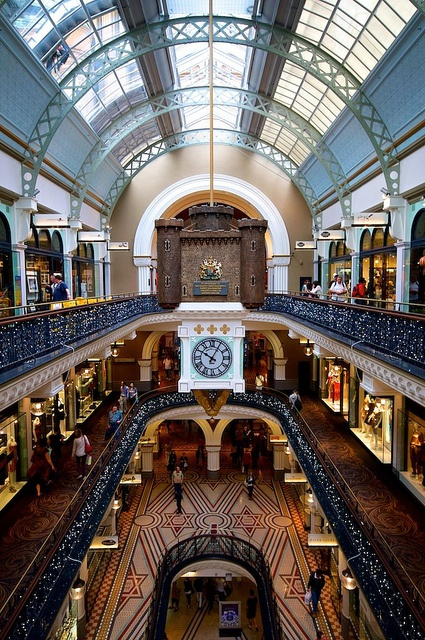Describe the objects in this image and their specific colors. I can see people in teal, black, maroon, and gray tones, clock in teal, darkgray, gray, and black tones, people in teal, black, maroon, and brown tones, people in teal, black, maroon, and gray tones, and people in teal, black, maroon, and gray tones in this image. 